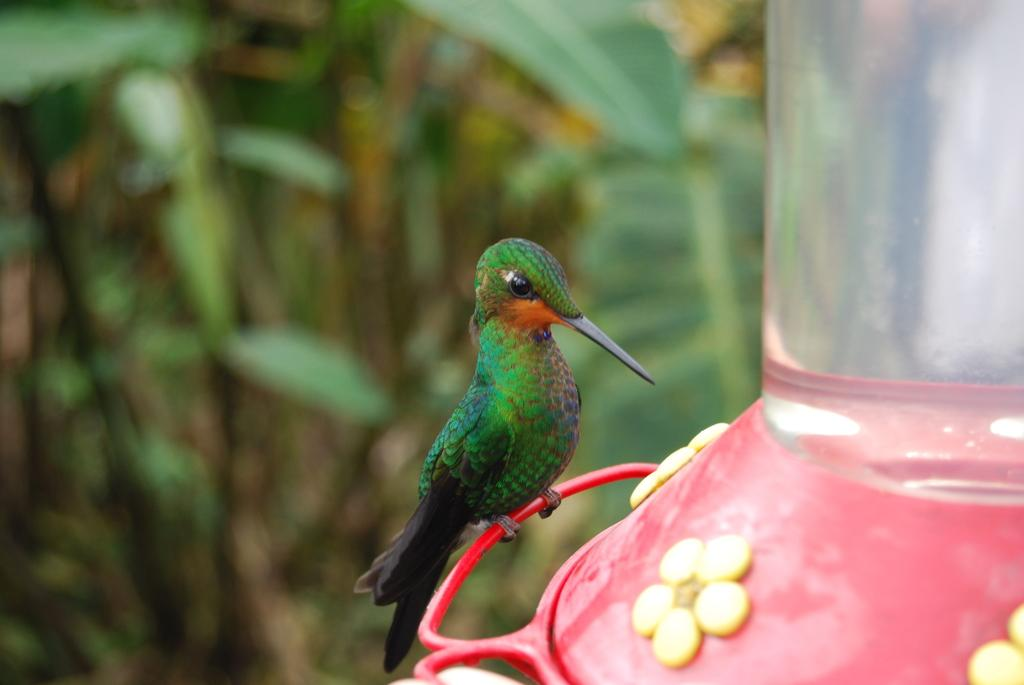What type of animal can be seen in the image? There is a bird in the image. What can be seen in the background of the image? There are plants in the background of the image. What is the title of the book the bird is reading in the image? There is no book or reading activity depicted in the image; it features a bird and plants in the background. 